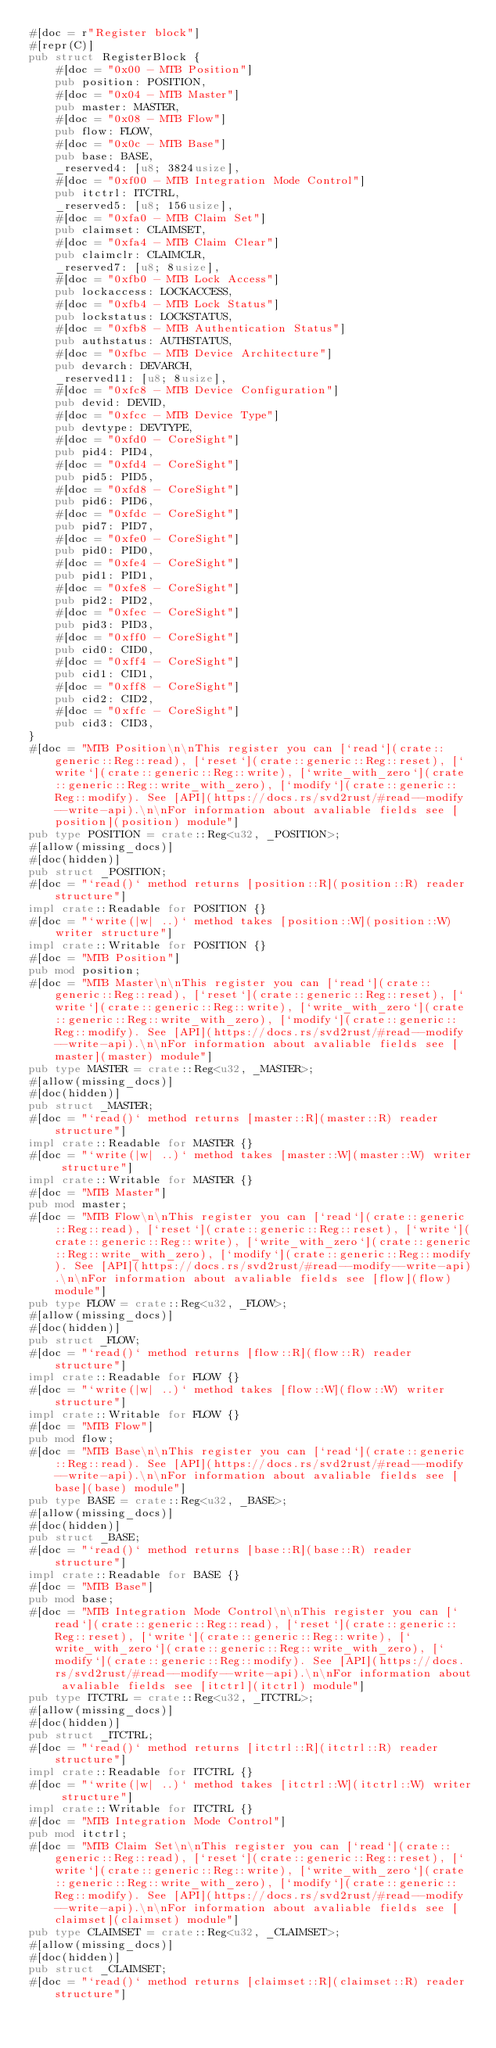<code> <loc_0><loc_0><loc_500><loc_500><_Rust_>#[doc = r"Register block"]
#[repr(C)]
pub struct RegisterBlock {
    #[doc = "0x00 - MTB Position"]
    pub position: POSITION,
    #[doc = "0x04 - MTB Master"]
    pub master: MASTER,
    #[doc = "0x08 - MTB Flow"]
    pub flow: FLOW,
    #[doc = "0x0c - MTB Base"]
    pub base: BASE,
    _reserved4: [u8; 3824usize],
    #[doc = "0xf00 - MTB Integration Mode Control"]
    pub itctrl: ITCTRL,
    _reserved5: [u8; 156usize],
    #[doc = "0xfa0 - MTB Claim Set"]
    pub claimset: CLAIMSET,
    #[doc = "0xfa4 - MTB Claim Clear"]
    pub claimclr: CLAIMCLR,
    _reserved7: [u8; 8usize],
    #[doc = "0xfb0 - MTB Lock Access"]
    pub lockaccess: LOCKACCESS,
    #[doc = "0xfb4 - MTB Lock Status"]
    pub lockstatus: LOCKSTATUS,
    #[doc = "0xfb8 - MTB Authentication Status"]
    pub authstatus: AUTHSTATUS,
    #[doc = "0xfbc - MTB Device Architecture"]
    pub devarch: DEVARCH,
    _reserved11: [u8; 8usize],
    #[doc = "0xfc8 - MTB Device Configuration"]
    pub devid: DEVID,
    #[doc = "0xfcc - MTB Device Type"]
    pub devtype: DEVTYPE,
    #[doc = "0xfd0 - CoreSight"]
    pub pid4: PID4,
    #[doc = "0xfd4 - CoreSight"]
    pub pid5: PID5,
    #[doc = "0xfd8 - CoreSight"]
    pub pid6: PID6,
    #[doc = "0xfdc - CoreSight"]
    pub pid7: PID7,
    #[doc = "0xfe0 - CoreSight"]
    pub pid0: PID0,
    #[doc = "0xfe4 - CoreSight"]
    pub pid1: PID1,
    #[doc = "0xfe8 - CoreSight"]
    pub pid2: PID2,
    #[doc = "0xfec - CoreSight"]
    pub pid3: PID3,
    #[doc = "0xff0 - CoreSight"]
    pub cid0: CID0,
    #[doc = "0xff4 - CoreSight"]
    pub cid1: CID1,
    #[doc = "0xff8 - CoreSight"]
    pub cid2: CID2,
    #[doc = "0xffc - CoreSight"]
    pub cid3: CID3,
}
#[doc = "MTB Position\n\nThis register you can [`read`](crate::generic::Reg::read), [`reset`](crate::generic::Reg::reset), [`write`](crate::generic::Reg::write), [`write_with_zero`](crate::generic::Reg::write_with_zero), [`modify`](crate::generic::Reg::modify). See [API](https://docs.rs/svd2rust/#read--modify--write-api).\n\nFor information about avaliable fields see [position](position) module"]
pub type POSITION = crate::Reg<u32, _POSITION>;
#[allow(missing_docs)]
#[doc(hidden)]
pub struct _POSITION;
#[doc = "`read()` method returns [position::R](position::R) reader structure"]
impl crate::Readable for POSITION {}
#[doc = "`write(|w| ..)` method takes [position::W](position::W) writer structure"]
impl crate::Writable for POSITION {}
#[doc = "MTB Position"]
pub mod position;
#[doc = "MTB Master\n\nThis register you can [`read`](crate::generic::Reg::read), [`reset`](crate::generic::Reg::reset), [`write`](crate::generic::Reg::write), [`write_with_zero`](crate::generic::Reg::write_with_zero), [`modify`](crate::generic::Reg::modify). See [API](https://docs.rs/svd2rust/#read--modify--write-api).\n\nFor information about avaliable fields see [master](master) module"]
pub type MASTER = crate::Reg<u32, _MASTER>;
#[allow(missing_docs)]
#[doc(hidden)]
pub struct _MASTER;
#[doc = "`read()` method returns [master::R](master::R) reader structure"]
impl crate::Readable for MASTER {}
#[doc = "`write(|w| ..)` method takes [master::W](master::W) writer structure"]
impl crate::Writable for MASTER {}
#[doc = "MTB Master"]
pub mod master;
#[doc = "MTB Flow\n\nThis register you can [`read`](crate::generic::Reg::read), [`reset`](crate::generic::Reg::reset), [`write`](crate::generic::Reg::write), [`write_with_zero`](crate::generic::Reg::write_with_zero), [`modify`](crate::generic::Reg::modify). See [API](https://docs.rs/svd2rust/#read--modify--write-api).\n\nFor information about avaliable fields see [flow](flow) module"]
pub type FLOW = crate::Reg<u32, _FLOW>;
#[allow(missing_docs)]
#[doc(hidden)]
pub struct _FLOW;
#[doc = "`read()` method returns [flow::R](flow::R) reader structure"]
impl crate::Readable for FLOW {}
#[doc = "`write(|w| ..)` method takes [flow::W](flow::W) writer structure"]
impl crate::Writable for FLOW {}
#[doc = "MTB Flow"]
pub mod flow;
#[doc = "MTB Base\n\nThis register you can [`read`](crate::generic::Reg::read). See [API](https://docs.rs/svd2rust/#read--modify--write-api).\n\nFor information about avaliable fields see [base](base) module"]
pub type BASE = crate::Reg<u32, _BASE>;
#[allow(missing_docs)]
#[doc(hidden)]
pub struct _BASE;
#[doc = "`read()` method returns [base::R](base::R) reader structure"]
impl crate::Readable for BASE {}
#[doc = "MTB Base"]
pub mod base;
#[doc = "MTB Integration Mode Control\n\nThis register you can [`read`](crate::generic::Reg::read), [`reset`](crate::generic::Reg::reset), [`write`](crate::generic::Reg::write), [`write_with_zero`](crate::generic::Reg::write_with_zero), [`modify`](crate::generic::Reg::modify). See [API](https://docs.rs/svd2rust/#read--modify--write-api).\n\nFor information about avaliable fields see [itctrl](itctrl) module"]
pub type ITCTRL = crate::Reg<u32, _ITCTRL>;
#[allow(missing_docs)]
#[doc(hidden)]
pub struct _ITCTRL;
#[doc = "`read()` method returns [itctrl::R](itctrl::R) reader structure"]
impl crate::Readable for ITCTRL {}
#[doc = "`write(|w| ..)` method takes [itctrl::W](itctrl::W) writer structure"]
impl crate::Writable for ITCTRL {}
#[doc = "MTB Integration Mode Control"]
pub mod itctrl;
#[doc = "MTB Claim Set\n\nThis register you can [`read`](crate::generic::Reg::read), [`reset`](crate::generic::Reg::reset), [`write`](crate::generic::Reg::write), [`write_with_zero`](crate::generic::Reg::write_with_zero), [`modify`](crate::generic::Reg::modify). See [API](https://docs.rs/svd2rust/#read--modify--write-api).\n\nFor information about avaliable fields see [claimset](claimset) module"]
pub type CLAIMSET = crate::Reg<u32, _CLAIMSET>;
#[allow(missing_docs)]
#[doc(hidden)]
pub struct _CLAIMSET;
#[doc = "`read()` method returns [claimset::R](claimset::R) reader structure"]</code> 